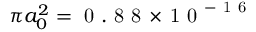Convert formula to latex. <formula><loc_0><loc_0><loc_500><loc_500>{ \pi a _ { 0 } ^ { 2 } = 0 . 8 8 \, \times \, 1 0 ^ { - 1 6 } }</formula> 